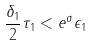Convert formula to latex. <formula><loc_0><loc_0><loc_500><loc_500>\frac { \delta _ { 1 } } { 2 } \tau _ { 1 } < e ^ { \sigma } \epsilon _ { 1 }</formula> 